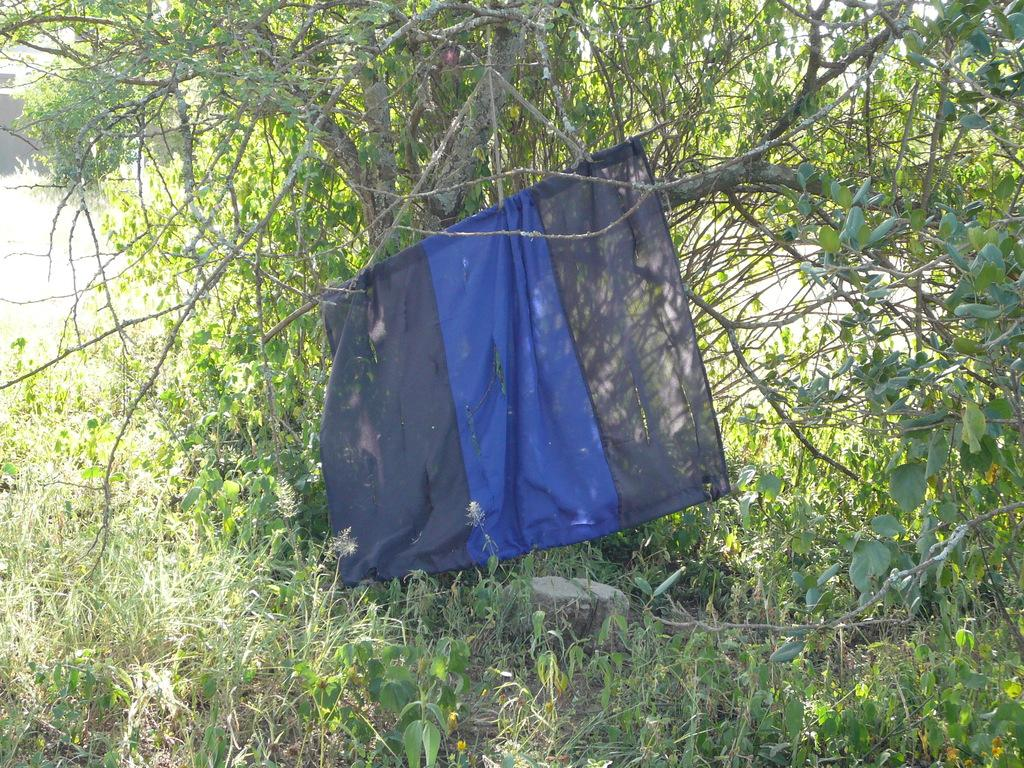What type of vegetation is present in the image? The image contains grass and trees. Can you describe the natural setting in the image? The natural setting includes grass and trees. What object can be seen between the trees in the image? A piece of cloth is visible between the trees. How many cherries can be seen hanging from the trees in the image? There are no cherries present in the image; it only features grass, trees, and a piece of cloth. What type of kitten is playing with the piece of cloth in the image? There is no kitten present in the image; only the piece of cloth is visible between the trees. 